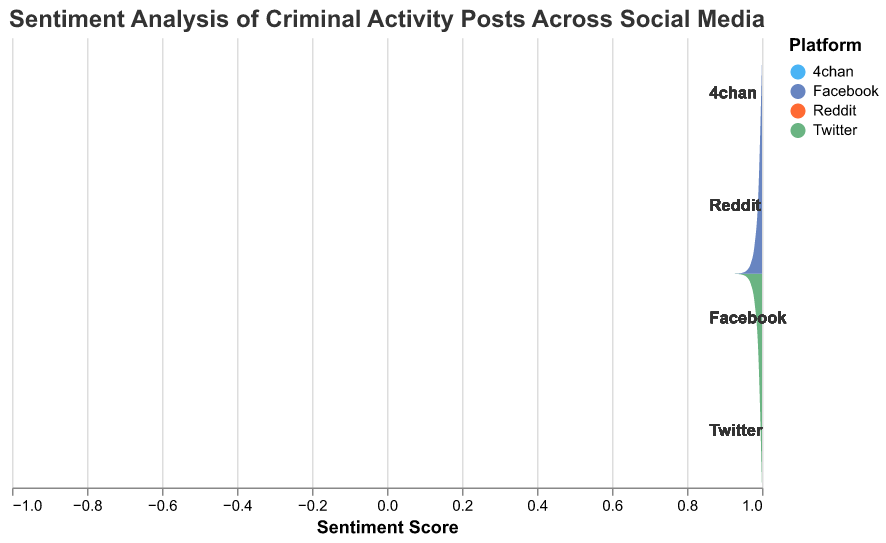What is the highest sentiment score shown in the 4chan platform? From the figure, look for the sentiment score with the highest frequency in the 4chan section (colored in its unique color). It's the value on the x-axis corresponding to the highest point in the area plot for 4chan.
Answer: 0 Which platform has the widest range of sentiment scores? To find the widest range, compare the spread of sentiment scores (x-axis) of each platform's distribution. The platform that covers the most sentiment scores has the widest range.
Answer: Reddit Which platform shows the lowest density for negative sentiment scores? Observe the height of the areas for negative sentiment scores (less than 0) and identify the platform with the lowest peak in this region.
Answer: Facebook How does the density of positive sentiment scores compare between Twitter and Reddit? Compare the height of the area for sentiment scores greater than 0 for both platforms. Look at the peak densities and overall area shapes for these positive scores.
Answer: Twitter has a higher density Is the peak density for neutral sentiment scores (score of 0) higher on Twitter or Facebook? Look at the area plot for Twitter and Facebook at the sentiment score of 0 and compare which has a higher peak density.
Answer: Twitter Which platform has a higher variability in sentiment scores, 4chan or Facebook? To determine variability, observe the spread and density distribution of sentiment scores for both platforms. The one with a more spread-out area plot has higher variability.
Answer: 4chan What is the primary color used for the Twitter platform in the plot? Identify the color used for the Twitter platform by looking at its area plot or the legend in the figure.
Answer: Blue For the sentiment score of 0.2, which platform has the highest frequency? Compare the frequency (height of the area plot) at the sentiment score of 0.2 across all platforms to see which one is the highest.
Answer: Facebook 